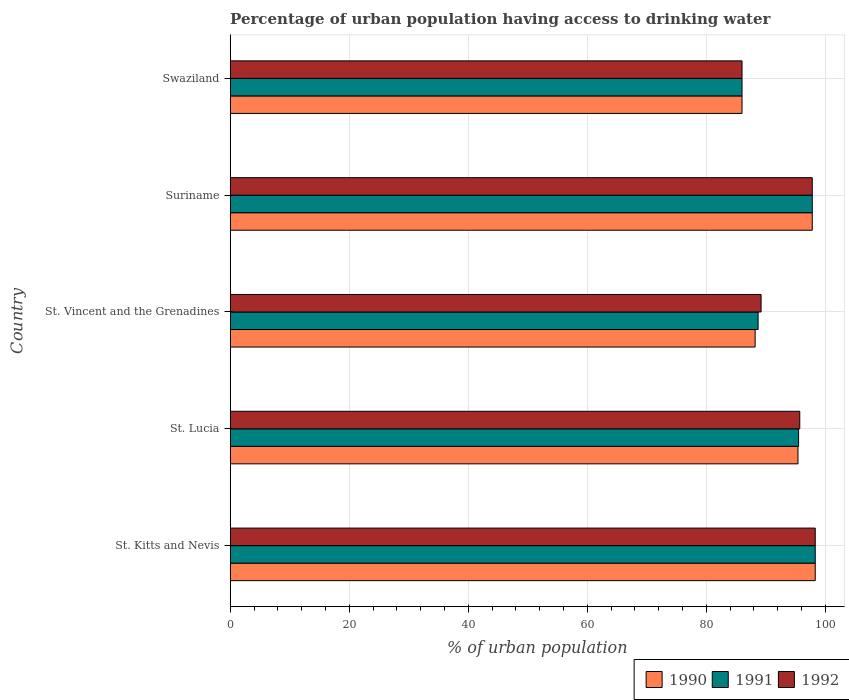How many different coloured bars are there?
Provide a succinct answer. 3. What is the label of the 2nd group of bars from the top?
Ensure brevity in your answer.  Suriname. What is the percentage of urban population having access to drinking water in 1991 in St. Lucia?
Offer a very short reply. 95.5. Across all countries, what is the maximum percentage of urban population having access to drinking water in 1992?
Make the answer very short. 98.3. Across all countries, what is the minimum percentage of urban population having access to drinking water in 1990?
Your answer should be compact. 86. In which country was the percentage of urban population having access to drinking water in 1992 maximum?
Provide a succinct answer. St. Kitts and Nevis. In which country was the percentage of urban population having access to drinking water in 1990 minimum?
Your answer should be very brief. Swaziland. What is the total percentage of urban population having access to drinking water in 1990 in the graph?
Make the answer very short. 465.7. What is the difference between the percentage of urban population having access to drinking water in 1991 in Suriname and that in Swaziland?
Provide a short and direct response. 11.8. What is the difference between the percentage of urban population having access to drinking water in 1990 in St. Vincent and the Grenadines and the percentage of urban population having access to drinking water in 1991 in St. Kitts and Nevis?
Ensure brevity in your answer.  -10.1. What is the average percentage of urban population having access to drinking water in 1991 per country?
Give a very brief answer. 93.26. What is the difference between the percentage of urban population having access to drinking water in 1992 and percentage of urban population having access to drinking water in 1991 in Swaziland?
Your answer should be very brief. 0. What is the ratio of the percentage of urban population having access to drinking water in 1990 in Suriname to that in Swaziland?
Provide a succinct answer. 1.14. Is the percentage of urban population having access to drinking water in 1990 in St. Kitts and Nevis less than that in Swaziland?
Offer a very short reply. No. What is the difference between the highest and the second highest percentage of urban population having access to drinking water in 1992?
Give a very brief answer. 0.5. What is the difference between the highest and the lowest percentage of urban population having access to drinking water in 1992?
Keep it short and to the point. 12.3. Is the sum of the percentage of urban population having access to drinking water in 1991 in Suriname and Swaziland greater than the maximum percentage of urban population having access to drinking water in 1992 across all countries?
Ensure brevity in your answer.  Yes. What does the 2nd bar from the top in St. Kitts and Nevis represents?
Keep it short and to the point. 1991. What does the 1st bar from the bottom in Suriname represents?
Provide a short and direct response. 1990. Is it the case that in every country, the sum of the percentage of urban population having access to drinking water in 1990 and percentage of urban population having access to drinking water in 1992 is greater than the percentage of urban population having access to drinking water in 1991?
Ensure brevity in your answer.  Yes. How many countries are there in the graph?
Offer a very short reply. 5. Does the graph contain grids?
Your response must be concise. Yes. How many legend labels are there?
Your answer should be very brief. 3. How are the legend labels stacked?
Your answer should be very brief. Horizontal. What is the title of the graph?
Ensure brevity in your answer.  Percentage of urban population having access to drinking water. Does "1972" appear as one of the legend labels in the graph?
Your answer should be very brief. No. What is the label or title of the X-axis?
Keep it short and to the point. % of urban population. What is the label or title of the Y-axis?
Provide a short and direct response. Country. What is the % of urban population in 1990 in St. Kitts and Nevis?
Your answer should be very brief. 98.3. What is the % of urban population in 1991 in St. Kitts and Nevis?
Give a very brief answer. 98.3. What is the % of urban population of 1992 in St. Kitts and Nevis?
Your response must be concise. 98.3. What is the % of urban population in 1990 in St. Lucia?
Offer a terse response. 95.4. What is the % of urban population of 1991 in St. Lucia?
Your answer should be very brief. 95.5. What is the % of urban population of 1992 in St. Lucia?
Ensure brevity in your answer.  95.7. What is the % of urban population of 1990 in St. Vincent and the Grenadines?
Offer a very short reply. 88.2. What is the % of urban population in 1991 in St. Vincent and the Grenadines?
Offer a terse response. 88.7. What is the % of urban population in 1992 in St. Vincent and the Grenadines?
Your answer should be very brief. 89.2. What is the % of urban population of 1990 in Suriname?
Give a very brief answer. 97.8. What is the % of urban population in 1991 in Suriname?
Provide a short and direct response. 97.8. What is the % of urban population in 1992 in Suriname?
Offer a terse response. 97.8. What is the % of urban population in 1992 in Swaziland?
Your answer should be very brief. 86. Across all countries, what is the maximum % of urban population of 1990?
Keep it short and to the point. 98.3. Across all countries, what is the maximum % of urban population of 1991?
Offer a very short reply. 98.3. Across all countries, what is the maximum % of urban population of 1992?
Keep it short and to the point. 98.3. Across all countries, what is the minimum % of urban population in 1990?
Make the answer very short. 86. What is the total % of urban population in 1990 in the graph?
Give a very brief answer. 465.7. What is the total % of urban population of 1991 in the graph?
Provide a short and direct response. 466.3. What is the total % of urban population in 1992 in the graph?
Your answer should be very brief. 467. What is the difference between the % of urban population of 1990 in St. Kitts and Nevis and that in St. Vincent and the Grenadines?
Your answer should be very brief. 10.1. What is the difference between the % of urban population in 1991 in St. Kitts and Nevis and that in St. Vincent and the Grenadines?
Offer a very short reply. 9.6. What is the difference between the % of urban population in 1992 in St. Kitts and Nevis and that in St. Vincent and the Grenadines?
Keep it short and to the point. 9.1. What is the difference between the % of urban population of 1990 in St. Kitts and Nevis and that in Suriname?
Make the answer very short. 0.5. What is the difference between the % of urban population of 1990 in St. Kitts and Nevis and that in Swaziland?
Provide a succinct answer. 12.3. What is the difference between the % of urban population of 1991 in St. Kitts and Nevis and that in Swaziland?
Your answer should be compact. 12.3. What is the difference between the % of urban population in 1992 in St. Kitts and Nevis and that in Swaziland?
Your answer should be compact. 12.3. What is the difference between the % of urban population in 1990 in St. Lucia and that in St. Vincent and the Grenadines?
Provide a short and direct response. 7.2. What is the difference between the % of urban population of 1990 in St. Lucia and that in Suriname?
Offer a terse response. -2.4. What is the difference between the % of urban population of 1992 in St. Lucia and that in Suriname?
Keep it short and to the point. -2.1. What is the difference between the % of urban population of 1990 in St. Lucia and that in Swaziland?
Keep it short and to the point. 9.4. What is the difference between the % of urban population of 1991 in St. Lucia and that in Swaziland?
Ensure brevity in your answer.  9.5. What is the difference between the % of urban population of 1990 in St. Vincent and the Grenadines and that in Suriname?
Give a very brief answer. -9.6. What is the difference between the % of urban population of 1991 in St. Vincent and the Grenadines and that in Suriname?
Your response must be concise. -9.1. What is the difference between the % of urban population of 1992 in St. Vincent and the Grenadines and that in Suriname?
Provide a succinct answer. -8.6. What is the difference between the % of urban population in 1990 in Suriname and that in Swaziland?
Provide a short and direct response. 11.8. What is the difference between the % of urban population in 1991 in Suriname and that in Swaziland?
Offer a terse response. 11.8. What is the difference between the % of urban population in 1992 in Suriname and that in Swaziland?
Make the answer very short. 11.8. What is the difference between the % of urban population in 1990 in St. Kitts and Nevis and the % of urban population in 1991 in St. Lucia?
Keep it short and to the point. 2.8. What is the difference between the % of urban population in 1991 in St. Kitts and Nevis and the % of urban population in 1992 in St. Lucia?
Provide a short and direct response. 2.6. What is the difference between the % of urban population of 1990 in St. Kitts and Nevis and the % of urban population of 1992 in St. Vincent and the Grenadines?
Your answer should be very brief. 9.1. What is the difference between the % of urban population in 1991 in St. Kitts and Nevis and the % of urban population in 1992 in Suriname?
Offer a very short reply. 0.5. What is the difference between the % of urban population in 1990 in St. Kitts and Nevis and the % of urban population in 1991 in Swaziland?
Offer a very short reply. 12.3. What is the difference between the % of urban population of 1990 in St. Kitts and Nevis and the % of urban population of 1992 in Swaziland?
Offer a very short reply. 12.3. What is the difference between the % of urban population in 1991 in St. Kitts and Nevis and the % of urban population in 1992 in Swaziland?
Offer a terse response. 12.3. What is the difference between the % of urban population in 1990 in St. Lucia and the % of urban population in 1992 in St. Vincent and the Grenadines?
Your answer should be compact. 6.2. What is the difference between the % of urban population of 1990 in St. Lucia and the % of urban population of 1991 in Suriname?
Provide a short and direct response. -2.4. What is the difference between the % of urban population of 1990 in St. Lucia and the % of urban population of 1992 in Suriname?
Your answer should be compact. -2.4. What is the difference between the % of urban population in 1991 in St. Lucia and the % of urban population in 1992 in Suriname?
Offer a very short reply. -2.3. What is the difference between the % of urban population of 1990 in St. Lucia and the % of urban population of 1992 in Swaziland?
Ensure brevity in your answer.  9.4. What is the difference between the % of urban population in 1991 in St. Vincent and the Grenadines and the % of urban population in 1992 in Swaziland?
Give a very brief answer. 2.7. What is the difference between the % of urban population of 1990 in Suriname and the % of urban population of 1991 in Swaziland?
Provide a succinct answer. 11.8. What is the difference between the % of urban population of 1990 in Suriname and the % of urban population of 1992 in Swaziland?
Offer a terse response. 11.8. What is the average % of urban population in 1990 per country?
Your answer should be compact. 93.14. What is the average % of urban population in 1991 per country?
Your answer should be very brief. 93.26. What is the average % of urban population in 1992 per country?
Keep it short and to the point. 93.4. What is the difference between the % of urban population in 1990 and % of urban population in 1991 in St. Kitts and Nevis?
Your answer should be very brief. 0. What is the difference between the % of urban population of 1990 and % of urban population of 1991 in St. Lucia?
Your answer should be very brief. -0.1. What is the difference between the % of urban population of 1990 and % of urban population of 1991 in St. Vincent and the Grenadines?
Your response must be concise. -0.5. What is the difference between the % of urban population of 1990 and % of urban population of 1992 in St. Vincent and the Grenadines?
Your answer should be very brief. -1. What is the difference between the % of urban population in 1991 and % of urban population in 1992 in St. Vincent and the Grenadines?
Offer a very short reply. -0.5. What is the difference between the % of urban population in 1990 and % of urban population in 1992 in Swaziland?
Your answer should be very brief. 0. What is the difference between the % of urban population of 1991 and % of urban population of 1992 in Swaziland?
Ensure brevity in your answer.  0. What is the ratio of the % of urban population of 1990 in St. Kitts and Nevis to that in St. Lucia?
Offer a terse response. 1.03. What is the ratio of the % of urban population of 1991 in St. Kitts and Nevis to that in St. Lucia?
Make the answer very short. 1.03. What is the ratio of the % of urban population of 1992 in St. Kitts and Nevis to that in St. Lucia?
Offer a very short reply. 1.03. What is the ratio of the % of urban population in 1990 in St. Kitts and Nevis to that in St. Vincent and the Grenadines?
Keep it short and to the point. 1.11. What is the ratio of the % of urban population of 1991 in St. Kitts and Nevis to that in St. Vincent and the Grenadines?
Offer a terse response. 1.11. What is the ratio of the % of urban population of 1992 in St. Kitts and Nevis to that in St. Vincent and the Grenadines?
Make the answer very short. 1.1. What is the ratio of the % of urban population in 1992 in St. Kitts and Nevis to that in Suriname?
Your response must be concise. 1.01. What is the ratio of the % of urban population in 1990 in St. Kitts and Nevis to that in Swaziland?
Ensure brevity in your answer.  1.14. What is the ratio of the % of urban population of 1991 in St. Kitts and Nevis to that in Swaziland?
Your answer should be very brief. 1.14. What is the ratio of the % of urban population in 1992 in St. Kitts and Nevis to that in Swaziland?
Ensure brevity in your answer.  1.14. What is the ratio of the % of urban population in 1990 in St. Lucia to that in St. Vincent and the Grenadines?
Ensure brevity in your answer.  1.08. What is the ratio of the % of urban population in 1991 in St. Lucia to that in St. Vincent and the Grenadines?
Ensure brevity in your answer.  1.08. What is the ratio of the % of urban population of 1992 in St. Lucia to that in St. Vincent and the Grenadines?
Provide a succinct answer. 1.07. What is the ratio of the % of urban population in 1990 in St. Lucia to that in Suriname?
Keep it short and to the point. 0.98. What is the ratio of the % of urban population of 1991 in St. Lucia to that in Suriname?
Provide a succinct answer. 0.98. What is the ratio of the % of urban population in 1992 in St. Lucia to that in Suriname?
Keep it short and to the point. 0.98. What is the ratio of the % of urban population of 1990 in St. Lucia to that in Swaziland?
Provide a short and direct response. 1.11. What is the ratio of the % of urban population of 1991 in St. Lucia to that in Swaziland?
Your response must be concise. 1.11. What is the ratio of the % of urban population of 1992 in St. Lucia to that in Swaziland?
Keep it short and to the point. 1.11. What is the ratio of the % of urban population of 1990 in St. Vincent and the Grenadines to that in Suriname?
Keep it short and to the point. 0.9. What is the ratio of the % of urban population in 1991 in St. Vincent and the Grenadines to that in Suriname?
Offer a very short reply. 0.91. What is the ratio of the % of urban population of 1992 in St. Vincent and the Grenadines to that in Suriname?
Your answer should be compact. 0.91. What is the ratio of the % of urban population in 1990 in St. Vincent and the Grenadines to that in Swaziland?
Keep it short and to the point. 1.03. What is the ratio of the % of urban population of 1991 in St. Vincent and the Grenadines to that in Swaziland?
Keep it short and to the point. 1.03. What is the ratio of the % of urban population of 1992 in St. Vincent and the Grenadines to that in Swaziland?
Provide a short and direct response. 1.04. What is the ratio of the % of urban population in 1990 in Suriname to that in Swaziland?
Provide a succinct answer. 1.14. What is the ratio of the % of urban population in 1991 in Suriname to that in Swaziland?
Offer a very short reply. 1.14. What is the ratio of the % of urban population of 1992 in Suriname to that in Swaziland?
Provide a short and direct response. 1.14. What is the difference between the highest and the second highest % of urban population in 1992?
Your answer should be very brief. 0.5. What is the difference between the highest and the lowest % of urban population of 1990?
Make the answer very short. 12.3. 